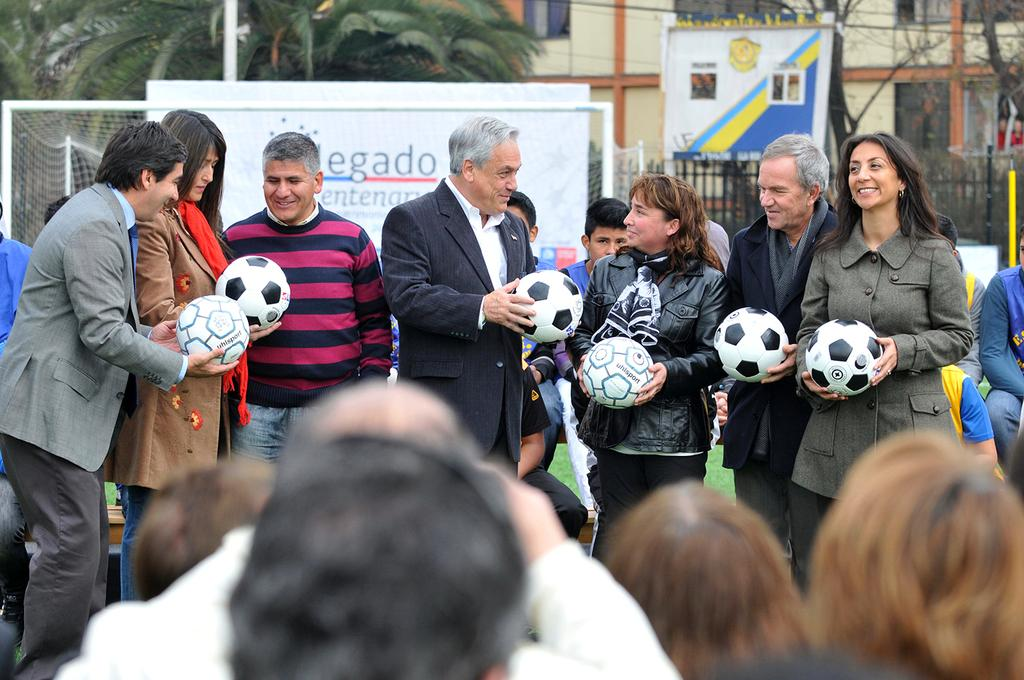How many people are in the image? There is a group of people in the image, but the exact number is not specified. What are the people doing in the image? The people are standing and holding footballs. What can be seen in the background of the image? There is a building, a tree, a board, and a court in the background of the image. What type of soda is being served at the game in the image? There is no game or soda present in the image; it features a group of people standing and holding footballs. What type of fork is being used to eat the food on the board in the image? There is no fork or food on a board present in the image; it only shows a group of people holding footballs and a background with a building, a tree, a board, and a court. 